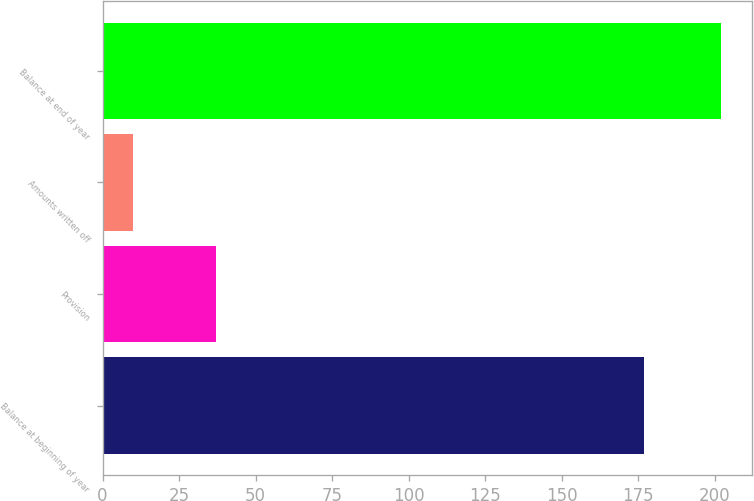Convert chart to OTSL. <chart><loc_0><loc_0><loc_500><loc_500><bar_chart><fcel>Balance at beginning of year<fcel>Provision<fcel>Amounts written off<fcel>Balance at end of year<nl><fcel>177<fcel>37<fcel>10<fcel>202<nl></chart> 